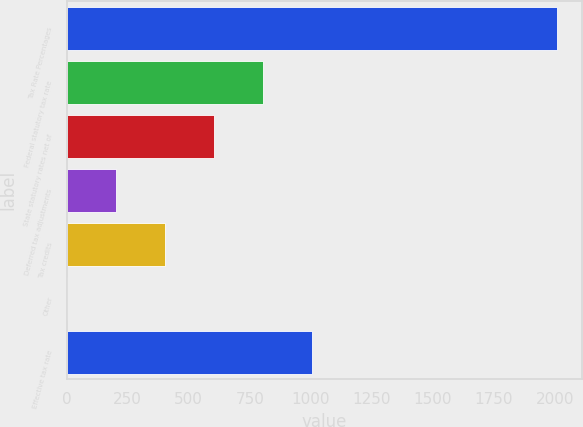Convert chart. <chart><loc_0><loc_0><loc_500><loc_500><bar_chart><fcel>Tax Rate Percentages<fcel>Federal statutory tax rate<fcel>State statutory rates net of<fcel>Deferred tax adjustments<fcel>Tax credits<fcel>Other<fcel>Effective tax rate<nl><fcel>2010<fcel>804.12<fcel>603.14<fcel>201.18<fcel>402.16<fcel>0.2<fcel>1005.1<nl></chart> 